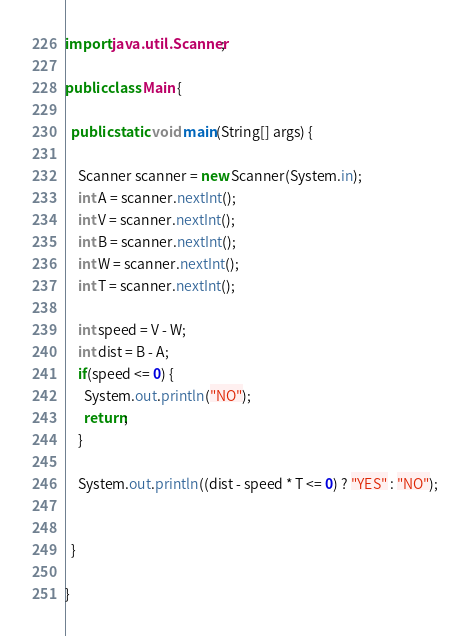Convert code to text. <code><loc_0><loc_0><loc_500><loc_500><_Java_>import java.util.Scanner;

public class Main {

  public static void main(String[] args) {

    Scanner scanner = new Scanner(System.in);
    int A = scanner.nextInt();
    int V = scanner.nextInt();
    int B = scanner.nextInt();
    int W = scanner.nextInt();
    int T = scanner.nextInt();

    int speed = V - W;
    int dist = B - A;
    if(speed <= 0) {
      System.out.println("NO");
      return;
    }

    System.out.println((dist - speed * T <= 0) ? "YES" : "NO");

              
  }

}
</code> 